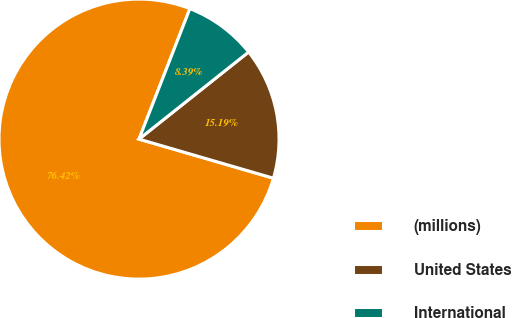<chart> <loc_0><loc_0><loc_500><loc_500><pie_chart><fcel>(millions)<fcel>United States<fcel>International<nl><fcel>76.41%<fcel>15.19%<fcel>8.39%<nl></chart> 